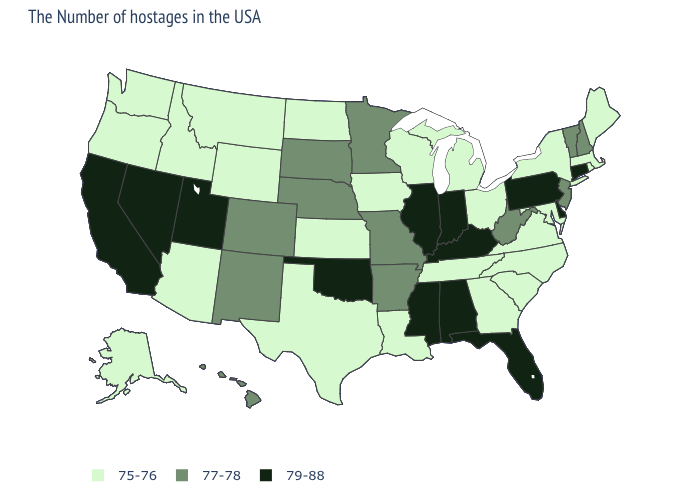Name the states that have a value in the range 79-88?
Short answer required. Connecticut, Delaware, Pennsylvania, Florida, Kentucky, Indiana, Alabama, Illinois, Mississippi, Oklahoma, Utah, Nevada, California. Does Illinois have the lowest value in the MidWest?
Write a very short answer. No. How many symbols are there in the legend?
Answer briefly. 3. Which states have the highest value in the USA?
Answer briefly. Connecticut, Delaware, Pennsylvania, Florida, Kentucky, Indiana, Alabama, Illinois, Mississippi, Oklahoma, Utah, Nevada, California. What is the value of Michigan?
Keep it brief. 75-76. What is the value of South Dakota?
Short answer required. 77-78. Does Kansas have the highest value in the MidWest?
Concise answer only. No. Does Maine have a lower value than Wisconsin?
Quick response, please. No. Which states have the lowest value in the USA?
Be succinct. Maine, Massachusetts, Rhode Island, New York, Maryland, Virginia, North Carolina, South Carolina, Ohio, Georgia, Michigan, Tennessee, Wisconsin, Louisiana, Iowa, Kansas, Texas, North Dakota, Wyoming, Montana, Arizona, Idaho, Washington, Oregon, Alaska. What is the value of Ohio?
Answer briefly. 75-76. Among the states that border North Dakota , which have the highest value?
Keep it brief. Minnesota, South Dakota. What is the highest value in the West ?
Write a very short answer. 79-88. Does Washington have the highest value in the West?
Write a very short answer. No. 